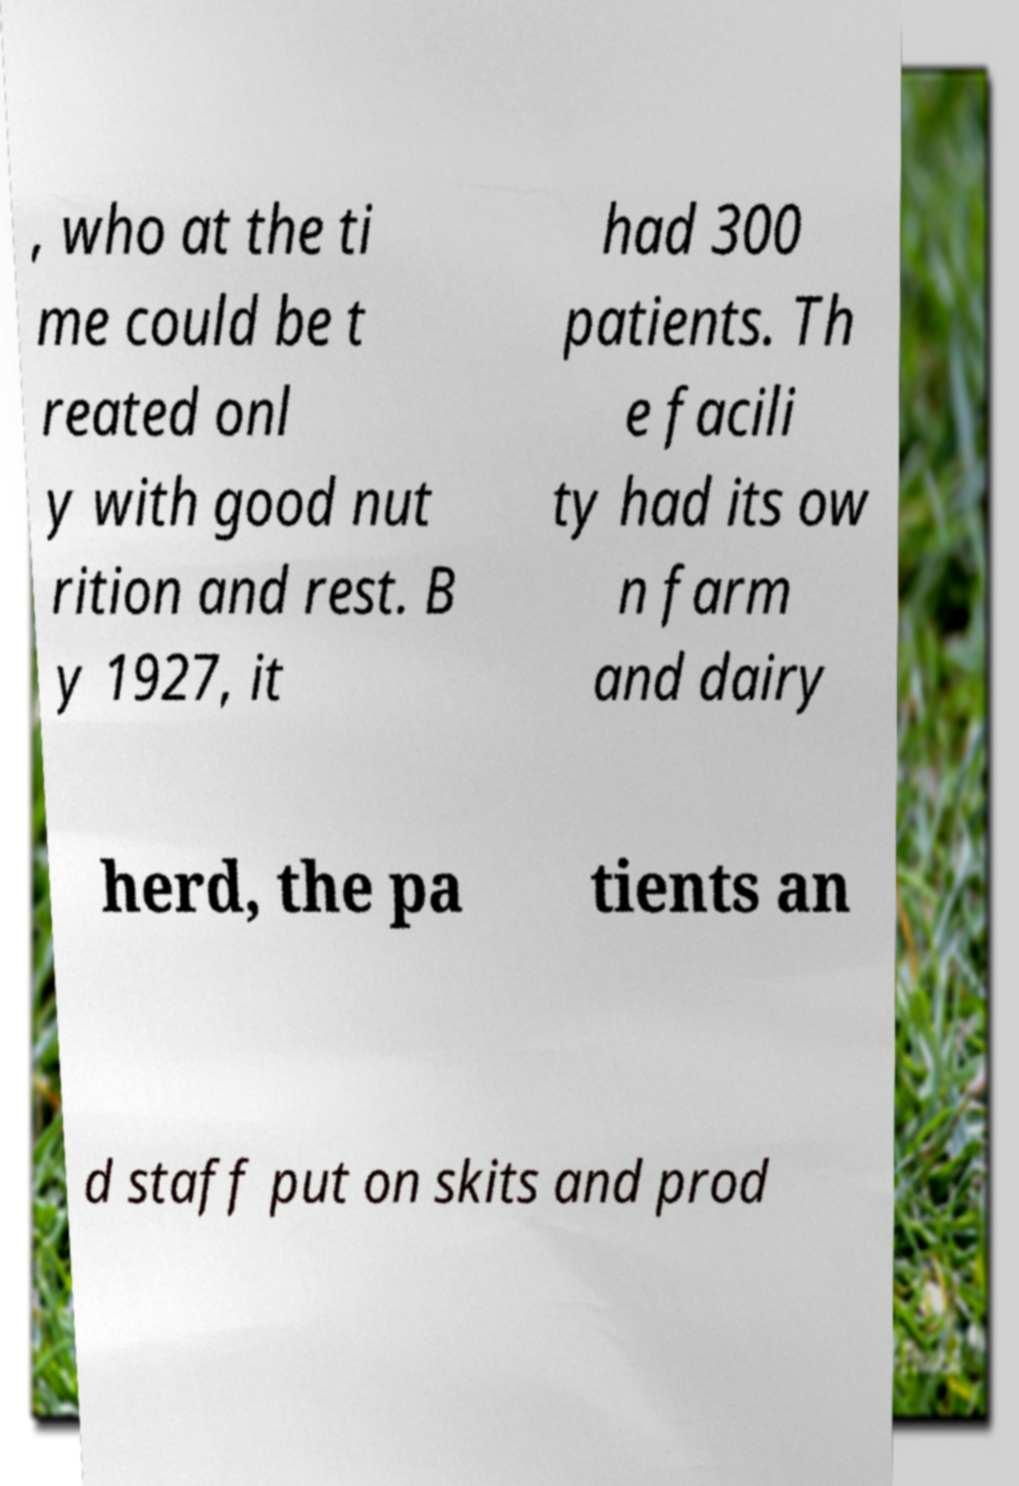Please identify and transcribe the text found in this image. , who at the ti me could be t reated onl y with good nut rition and rest. B y 1927, it had 300 patients. Th e facili ty had its ow n farm and dairy herd, the pa tients an d staff put on skits and prod 